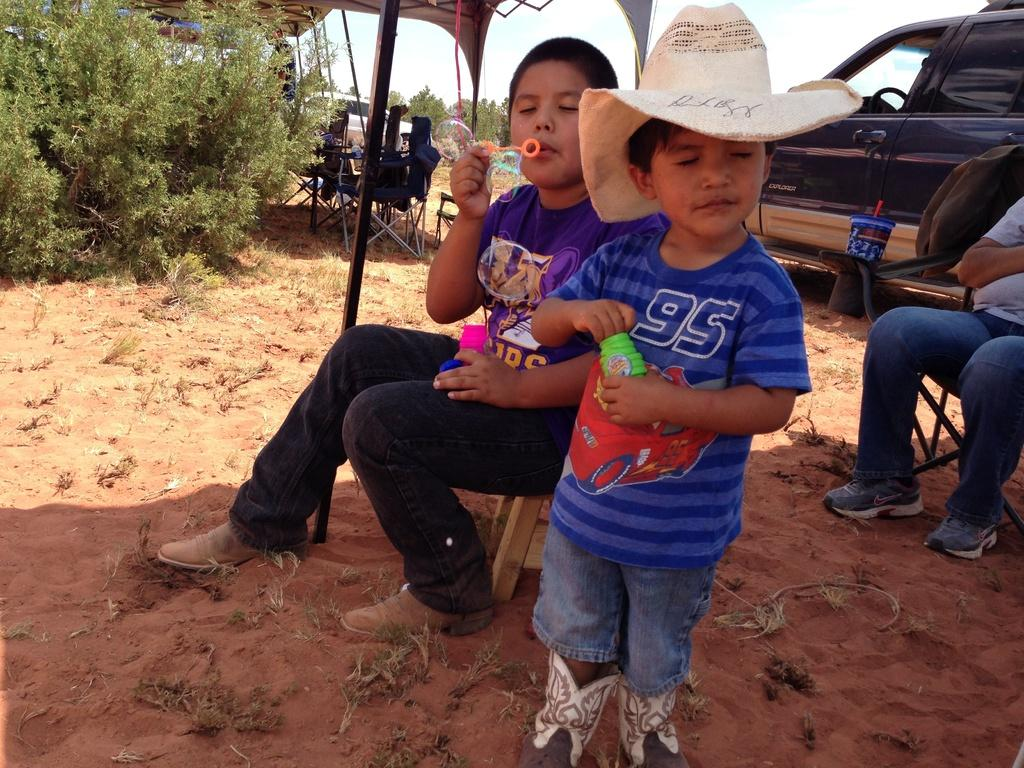What are the people in the image doing under the tent? The people in the image are playing. What can be seen in the background of the image? There are vehicles and plants visible in the image. How does the humor increase in the image? There is no indication of humor in the image, as it features people playing under a tent with vehicles and plants visible in the background. 